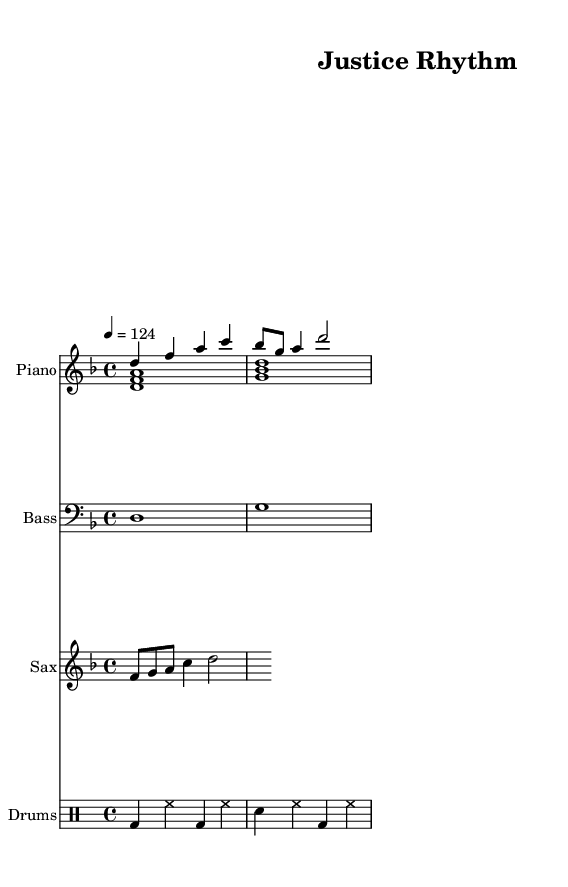What is the key signature of this music? The key signature is D minor, which has one flat (B flat). This is indicated by the sharped note F in the treble clef but shows a minor key overall.
Answer: D minor What is the time signature of this piece? The time signature is 4/4, which is shown at the start of the music. This means there are four beats in each measure.
Answer: 4/4 What is the tempo marking for this piece? The tempo marking is 124 beats per minute, indicating a moderately brisk pace for the music. It is explicitly stated in the header section indicating how fast the piece should be played.
Answer: 124 How many measures are present in the piano right hand part? There are 4 measures in the piano right-hand part, which can be counted from the notation provided. Each group of notes before the bar lines represents a measure.
Answer: 4 What instruments are featured in this composition? The instruments featured are Piano, Bass, Saxophone, and Drums. Each instrument’s part is notated in separate staves.
Answer: Piano, Bass, Saxophone, Drums What type of music is this composition? This composition is a Jazzy deep house tune, characterized by rhythmical piano and a danceable groove which celebrates African American legal pioneers.
Answer: Jazzy deep house 